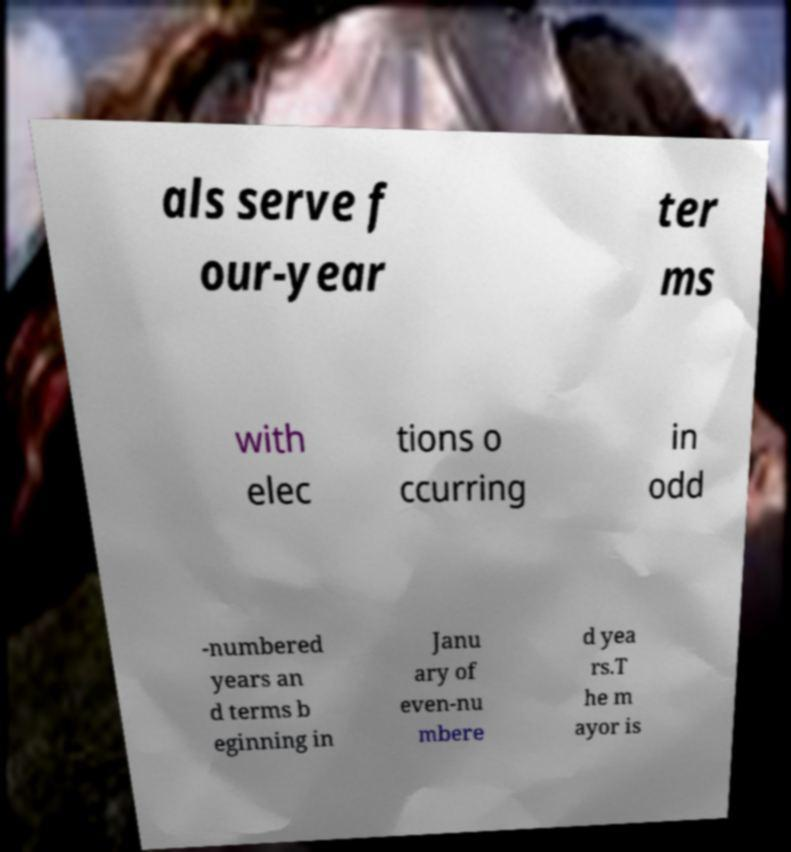Can you accurately transcribe the text from the provided image for me? als serve f our-year ter ms with elec tions o ccurring in odd -numbered years an d terms b eginning in Janu ary of even-nu mbere d yea rs.T he m ayor is 